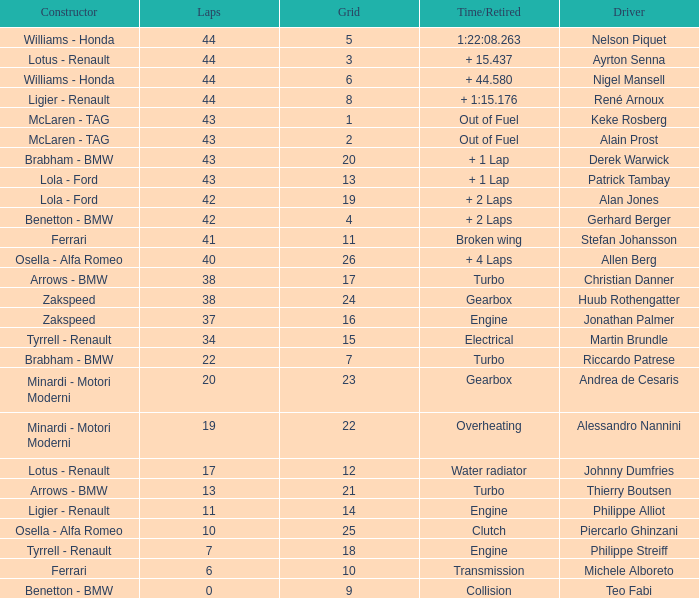I want the driver that has Laps of 10 Piercarlo Ghinzani. 